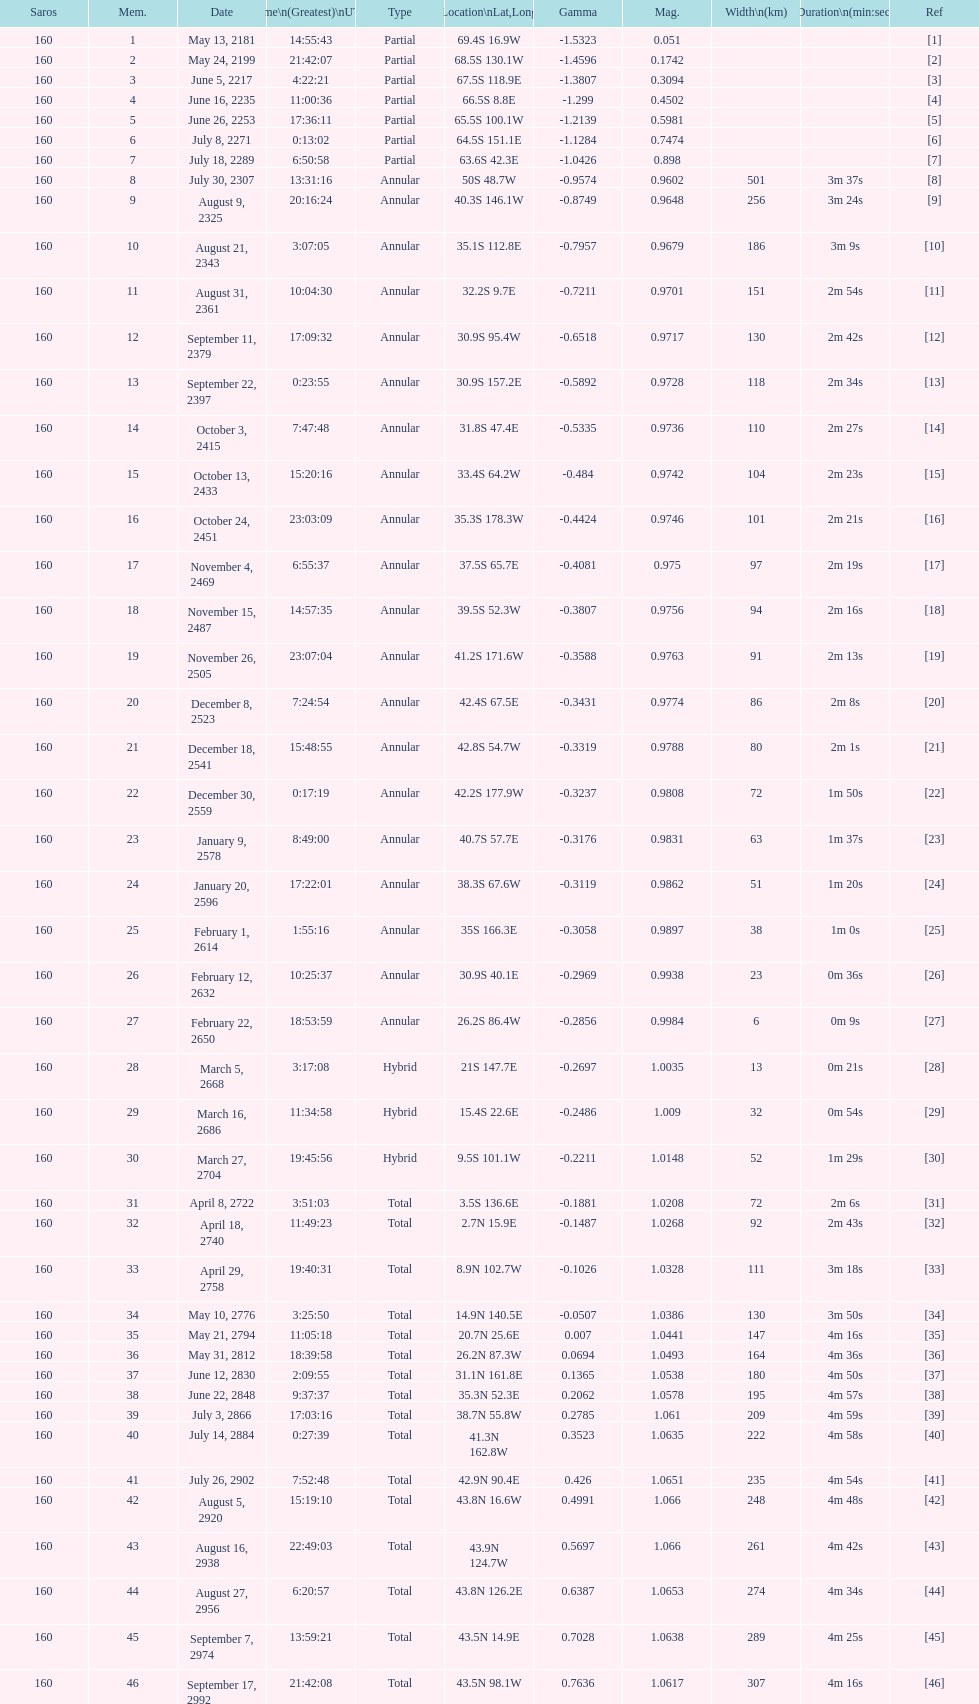What is the previous time for the saros on october 3, 2415? 7:47:48. 